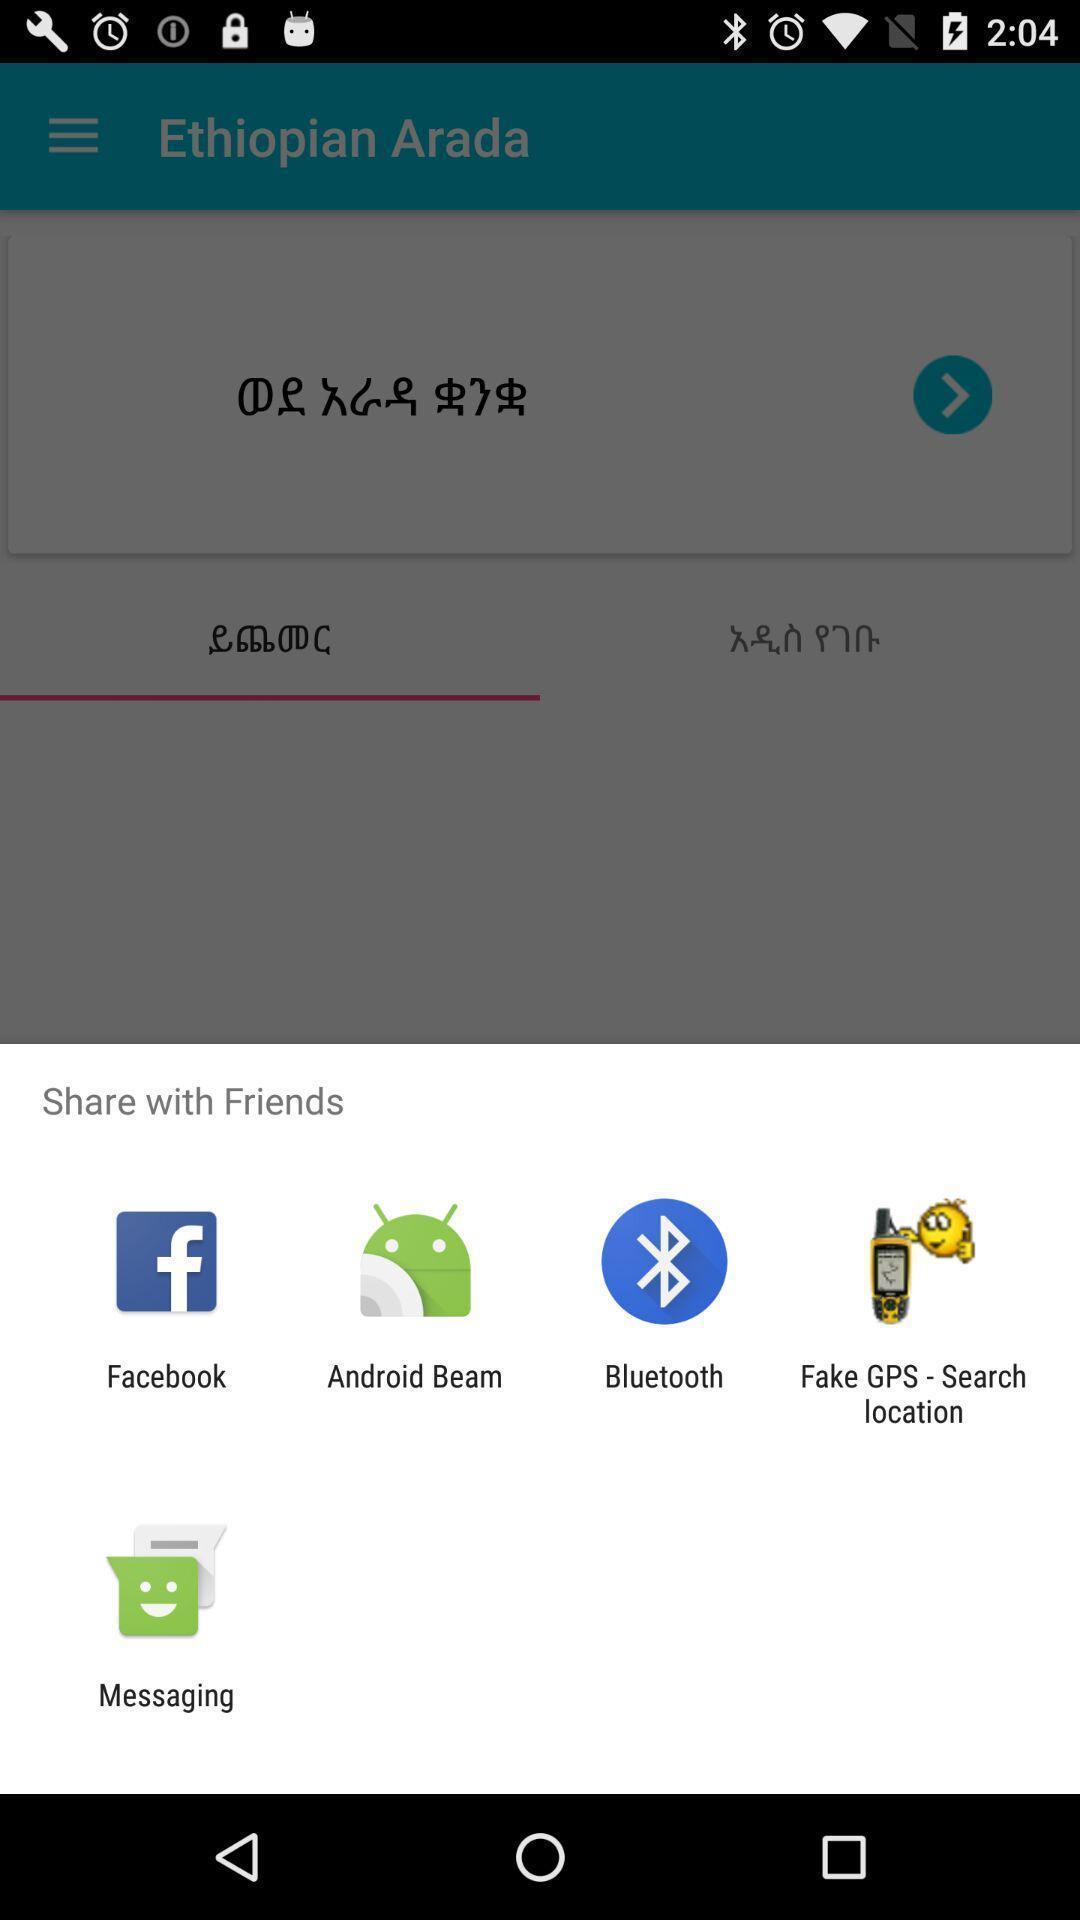Tell me about the visual elements in this screen capture. Share options page of a language app. 